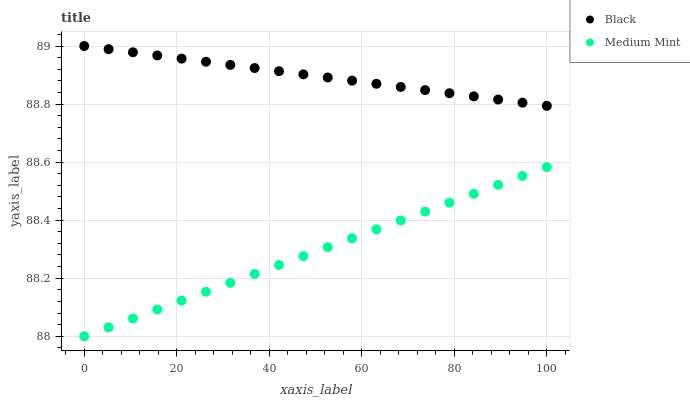Does Medium Mint have the minimum area under the curve?
Answer yes or no. Yes. Does Black have the maximum area under the curve?
Answer yes or no. Yes. Does Black have the minimum area under the curve?
Answer yes or no. No. Is Medium Mint the smoothest?
Answer yes or no. Yes. Is Black the roughest?
Answer yes or no. Yes. Is Black the smoothest?
Answer yes or no. No. Does Medium Mint have the lowest value?
Answer yes or no. Yes. Does Black have the lowest value?
Answer yes or no. No. Does Black have the highest value?
Answer yes or no. Yes. Is Medium Mint less than Black?
Answer yes or no. Yes. Is Black greater than Medium Mint?
Answer yes or no. Yes. Does Medium Mint intersect Black?
Answer yes or no. No. 